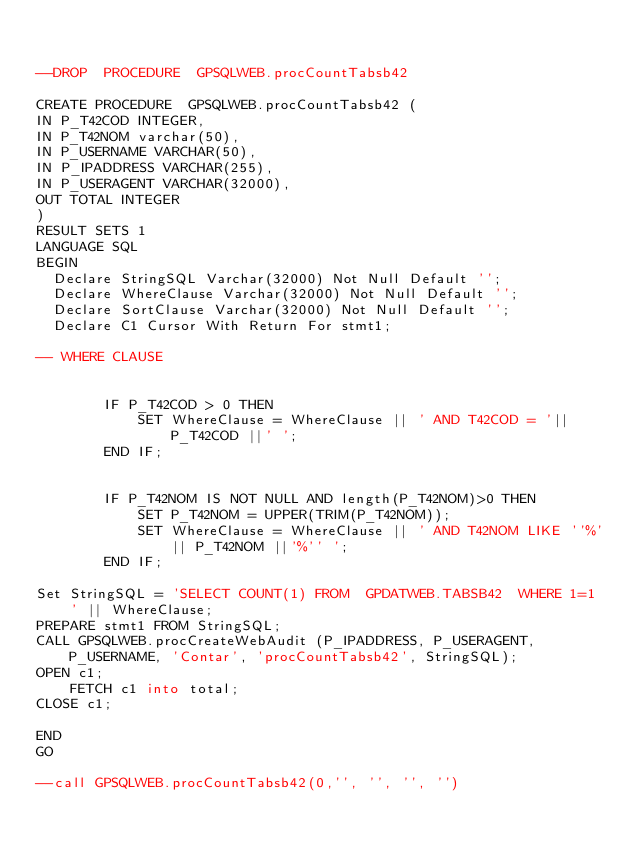<code> <loc_0><loc_0><loc_500><loc_500><_SQL_>

--DROP  PROCEDURE  GPSQLWEB.procCountTabsb42

CREATE PROCEDURE  GPSQLWEB.procCountTabsb42 (
IN P_T42COD INTEGER,
IN P_T42NOM varchar(50),
IN P_USERNAME VARCHAR(50),
IN P_IPADDRESS VARCHAR(255),
IN P_USERAGENT VARCHAR(32000),
OUT TOTAL INTEGER
)
RESULT SETS 1
LANGUAGE SQL
BEGIN
  Declare StringSQL Varchar(32000) Not Null Default '';
  Declare WhereClause Varchar(32000) Not Null Default '';
  Declare SortClause Varchar(32000) Not Null Default '';
  Declare C1 Cursor With Return For stmt1;

-- WHERE CLAUSE

        
        IF P_T42COD > 0 THEN
            SET WhereClause = WhereClause || ' AND T42COD = '|| P_T42COD ||' ';
        END IF;
    
        
        IF P_T42NOM IS NOT NULL AND length(P_T42NOM)>0 THEN
            SET P_T42NOM = UPPER(TRIM(P_T42NOM));
            SET WhereClause = WhereClause || ' AND T42NOM LIKE ''%'|| P_T42NOM ||'%'' ';
        END IF;
    
Set StringSQL = 'SELECT COUNT(1) FROM  GPDATWEB.TABSB42  WHERE 1=1 ' || WhereClause; 
PREPARE stmt1 FROM StringSQL;
CALL GPSQLWEB.procCreateWebAudit (P_IPADDRESS, P_USERAGENT, P_USERNAME, 'Contar', 'procCountTabsb42', StringSQL);
OPEN c1;
    FETCH c1 into total;
CLOSE c1;
    
END
GO

--call GPSQLWEB.procCountTabsb42(0,'', '', '', '')
</code> 